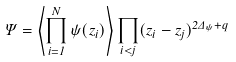<formula> <loc_0><loc_0><loc_500><loc_500>\Psi = \left \langle \prod _ { i = 1 } ^ { N } \psi ( z _ { i } ) \right \rangle \prod _ { i < j } ( z _ { i } - z _ { j } ) ^ { 2 \Delta _ { \psi } + q }</formula> 